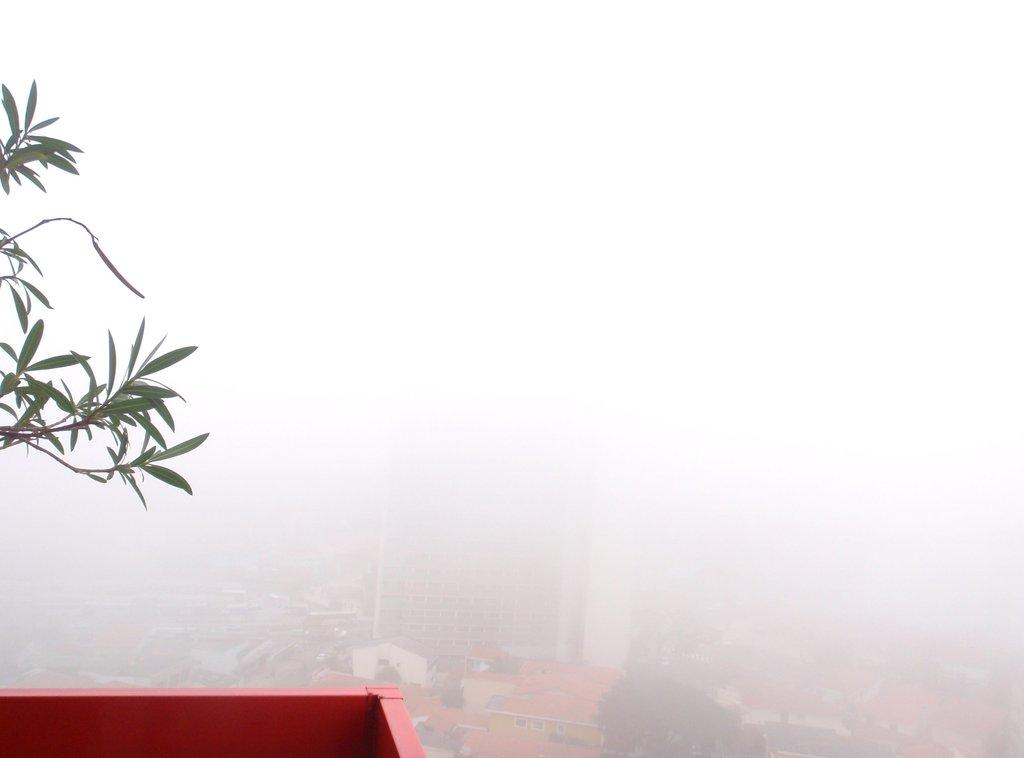What type of vegetation can be seen in the image? There are leaves in the image. What type of man-made structures are present in the image? There are buildings in the image. How would you describe the appearance of the sky in the image? The sky appears smoky in the image. Where is the coat hanging in the image? There is no coat present in the image. Can you tell me how many people are sleeping in the image? There is no one sleeping in the image. What type of party is taking place in the image? There is no party depicted in the image. 